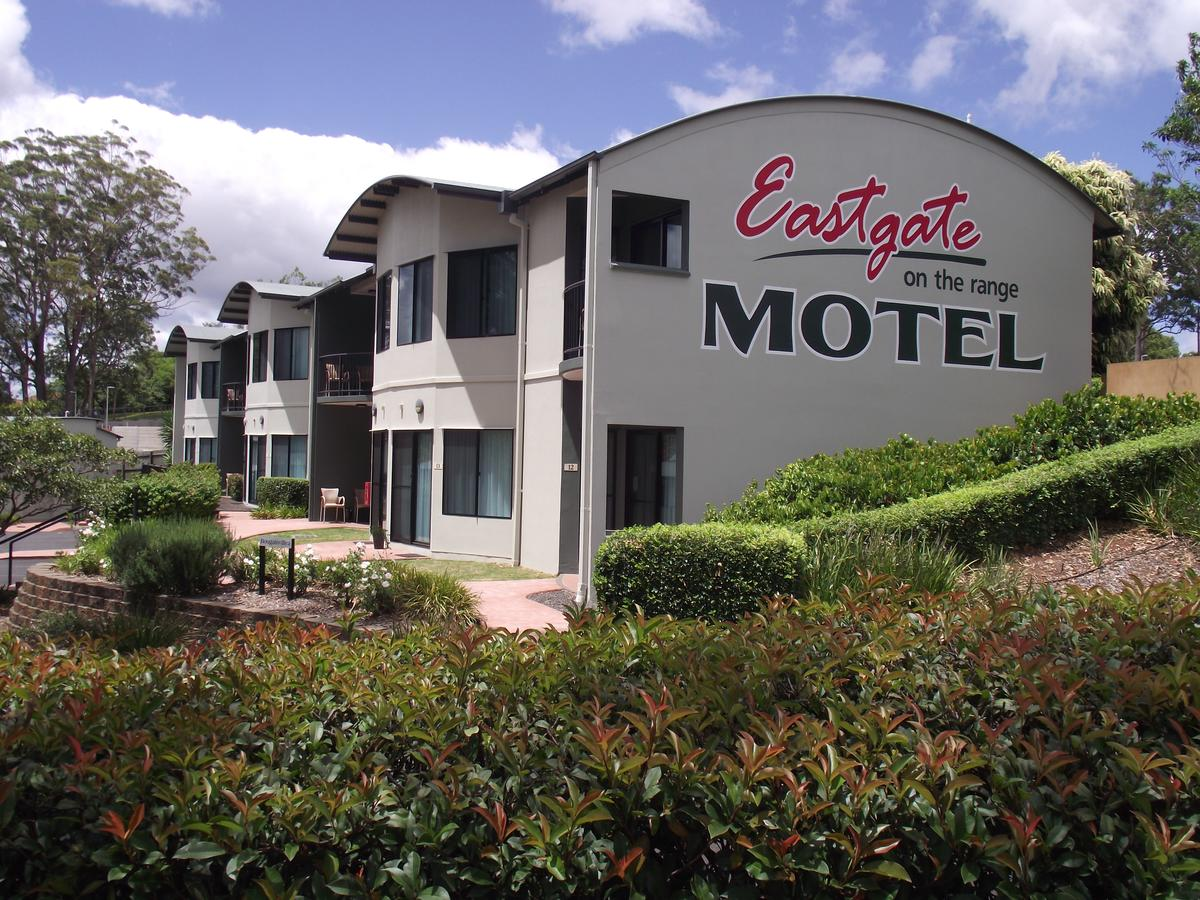What does the landscaping tell you about the climate or location of the motel? The presence of lush, green shrubbery and mature trees in the landscaping suggests a temperate climate that supports a variety of plant life. This might indicate that the motel is located in a region that experiences sufficient rainfall and moderate temperatures, ideal for maintaining such vibrant foliage. 